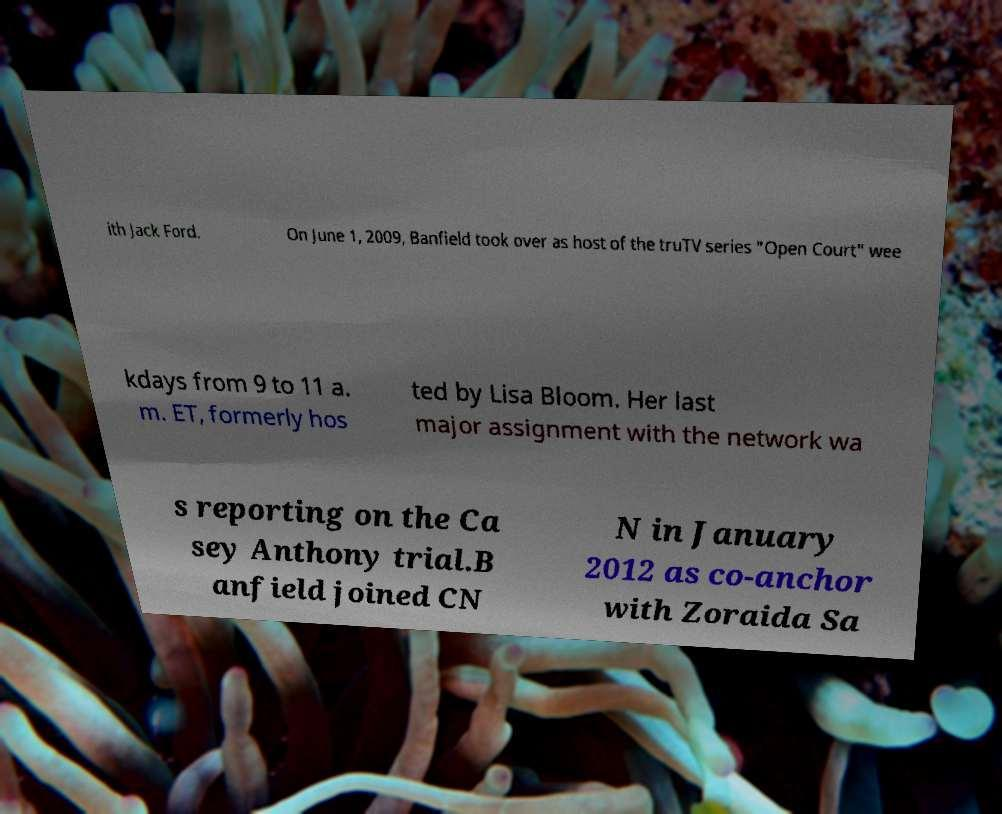I need the written content from this picture converted into text. Can you do that? ith Jack Ford. On June 1, 2009, Banfield took over as host of the truTV series "Open Court" wee kdays from 9 to 11 a. m. ET, formerly hos ted by Lisa Bloom. Her last major assignment with the network wa s reporting on the Ca sey Anthony trial.B anfield joined CN N in January 2012 as co-anchor with Zoraida Sa 